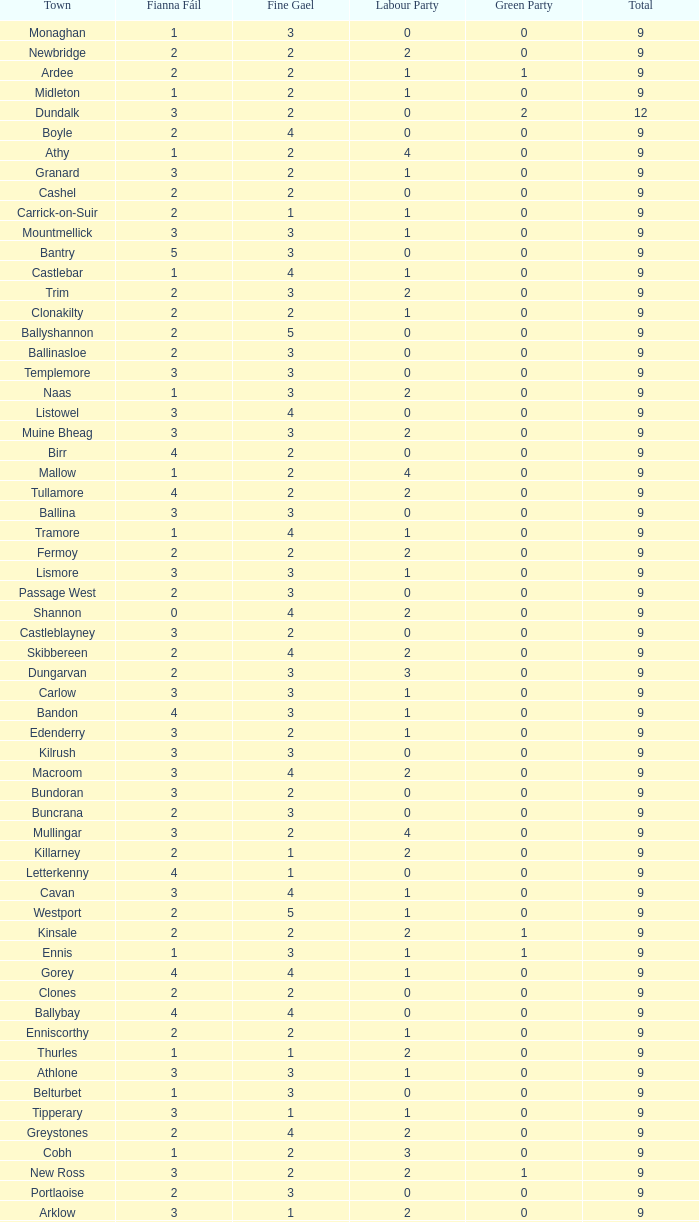How many are in the Labour Party of a Fianna Fail of 3 with a total higher than 9 and more than 2 in the Green Party? None. 